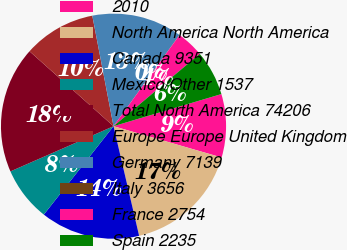Convert chart. <chart><loc_0><loc_0><loc_500><loc_500><pie_chart><fcel>2010<fcel>North America North America<fcel>Canada 9351<fcel>Mexico/Other 1537<fcel>Total North America 74206<fcel>Europe Europe United Kingdom<fcel>Germany 7139<fcel>Italy 3656<fcel>France 2754<fcel>Spain 2235<nl><fcel>9.09%<fcel>16.87%<fcel>14.28%<fcel>7.8%<fcel>18.17%<fcel>10.39%<fcel>12.98%<fcel>0.02%<fcel>3.91%<fcel>6.5%<nl></chart> 